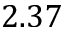Convert formula to latex. <formula><loc_0><loc_0><loc_500><loc_500>2 . 3 7</formula> 